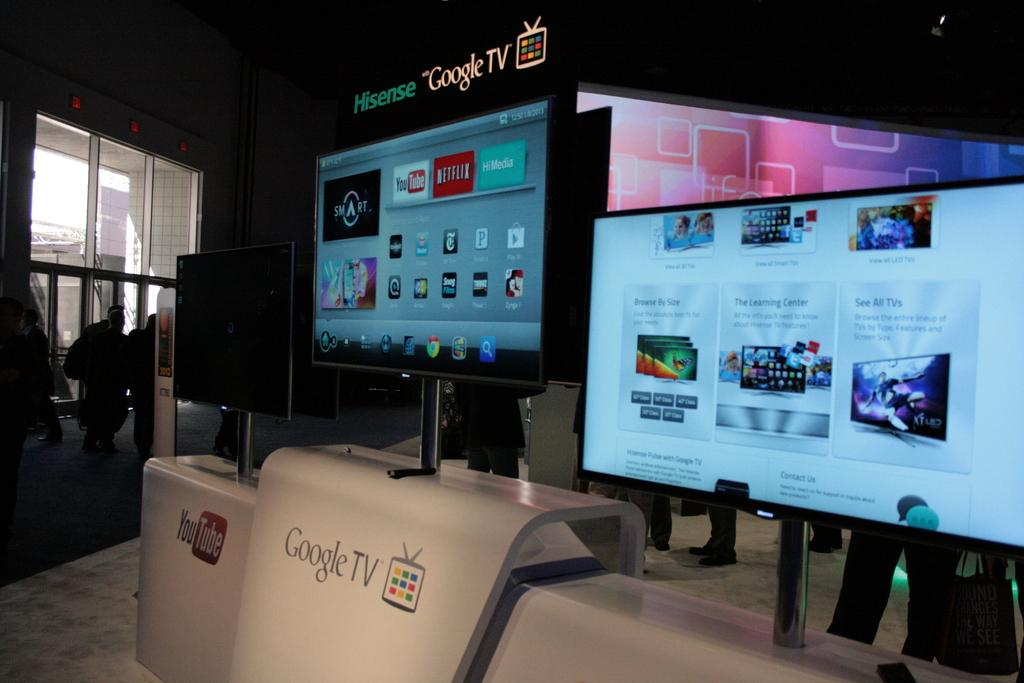<image>
Relay a brief, clear account of the picture shown. 2 google home tvs side by side both turned on 